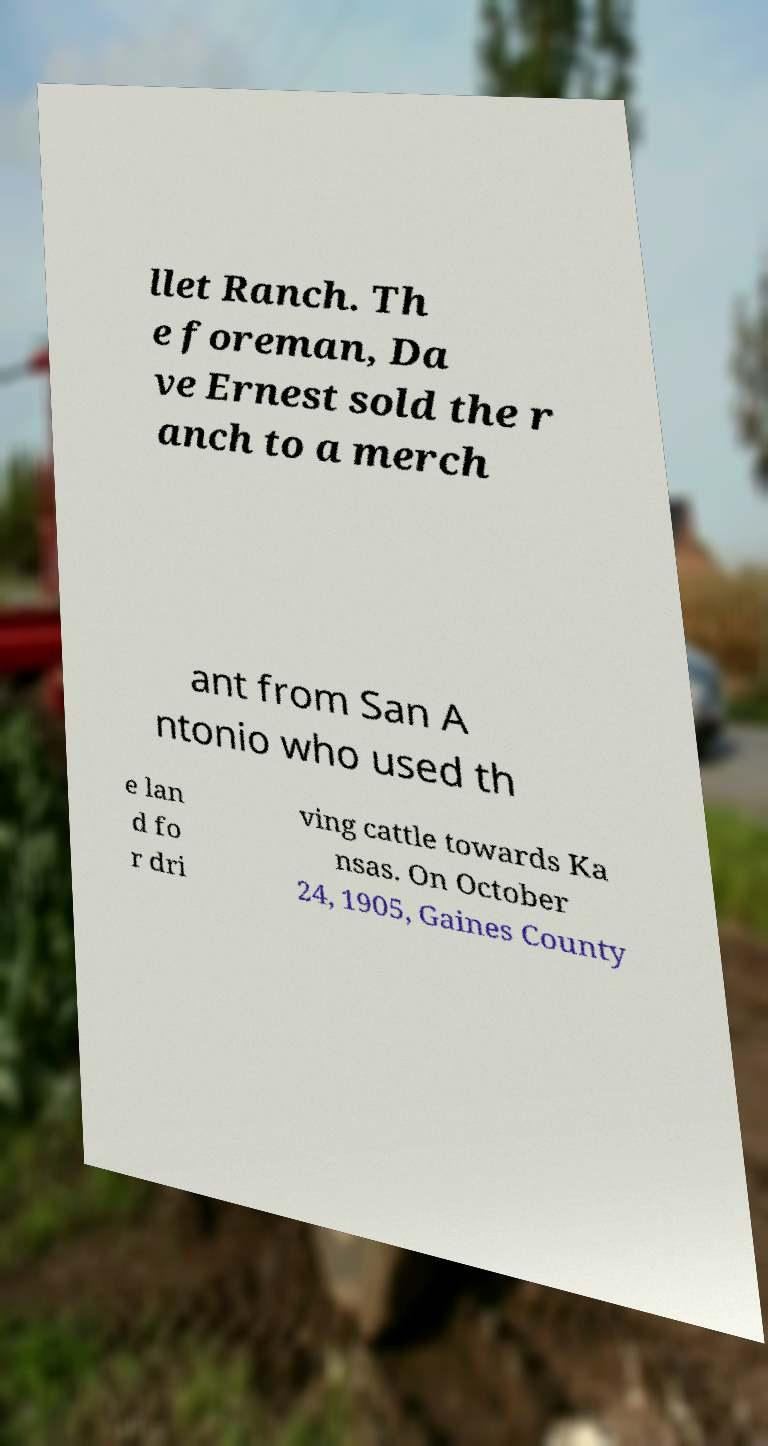There's text embedded in this image that I need extracted. Can you transcribe it verbatim? llet Ranch. Th e foreman, Da ve Ernest sold the r anch to a merch ant from San A ntonio who used th e lan d fo r dri ving cattle towards Ka nsas. On October 24, 1905, Gaines County 